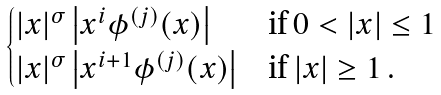<formula> <loc_0><loc_0><loc_500><loc_500>\begin{cases} | x | ^ { \sigma } \left | x ^ { i } \phi ^ { ( j ) } ( x ) \right | & \text {if $0<|x|\leq1$} \\ | x | ^ { \sigma } \left | x ^ { i + 1 } \phi ^ { ( j ) } ( x ) \right | & \text {if $|x|\geq1$} \, . \end{cases}</formula> 